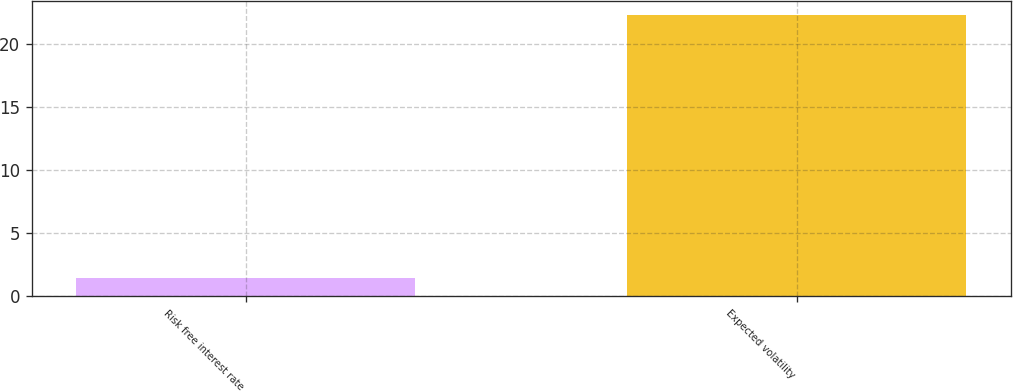<chart> <loc_0><loc_0><loc_500><loc_500><bar_chart><fcel>Risk free interest rate<fcel>Expected volatility<nl><fcel>1.44<fcel>22.3<nl></chart> 